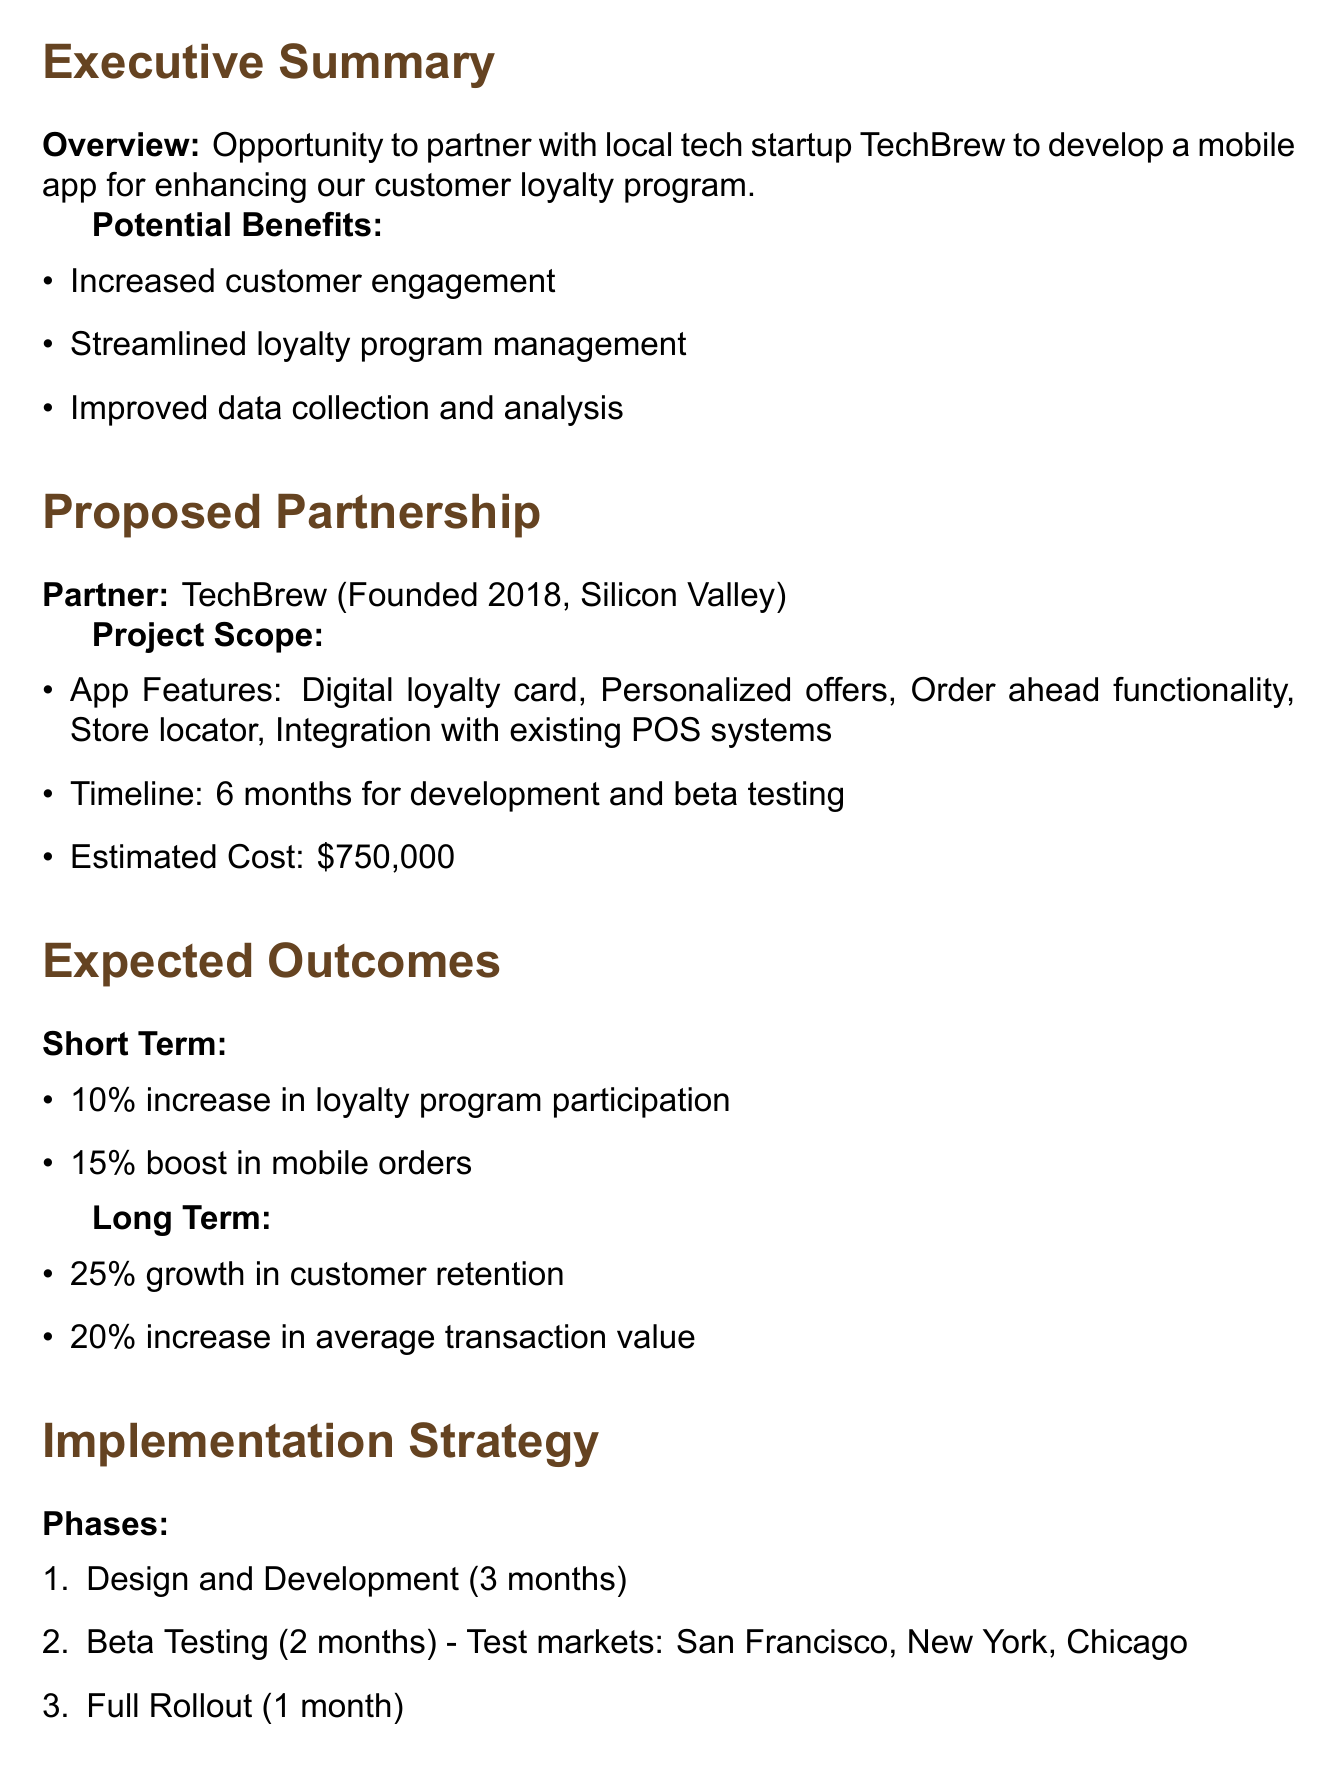what is the partner name? The partner name for the proposed partnership is mentioned in the document under the proposed partnership section.
Answer: TechBrew what is the estimated cost of the project? The estimated cost of the project is detailed in the project scope section of the memo.
Answer: $750,000 how many months is the timeline for development and beta testing? The timeline is stated in the project scope and includes both development and beta testing durations combined.
Answer: 6 months what percentage increase in loyalty program participation is expected in the short term? The expected outcomes section outlines the short-term expectations regarding loyalty program participation.
Answer: 10% what are the test markets for beta testing? The test markets are listed in the implementation strategy section under the beta testing phase.
Answer: San Francisco, New York, Chicago what is one potential risk mentioned in the risk assessment? The potential risks are identified in the risk assessment section and can be found listed there.
Answer: Data security concerns what is one key feature of the proposed app? The app features are outlined in the project scope, detailing capabilities that the app will have.
Answer: Digital loyalty card what is the expected long-term growth in customer retention? The expected long-term outcomes are provided in the expected outcomes section of the memo.
Answer: 25% what phase follows the beta testing phase in the implementation strategy? The phases of implementation are laid out in the implementation strategy section, indicating the order of phases.
Answer: Full Rollout 